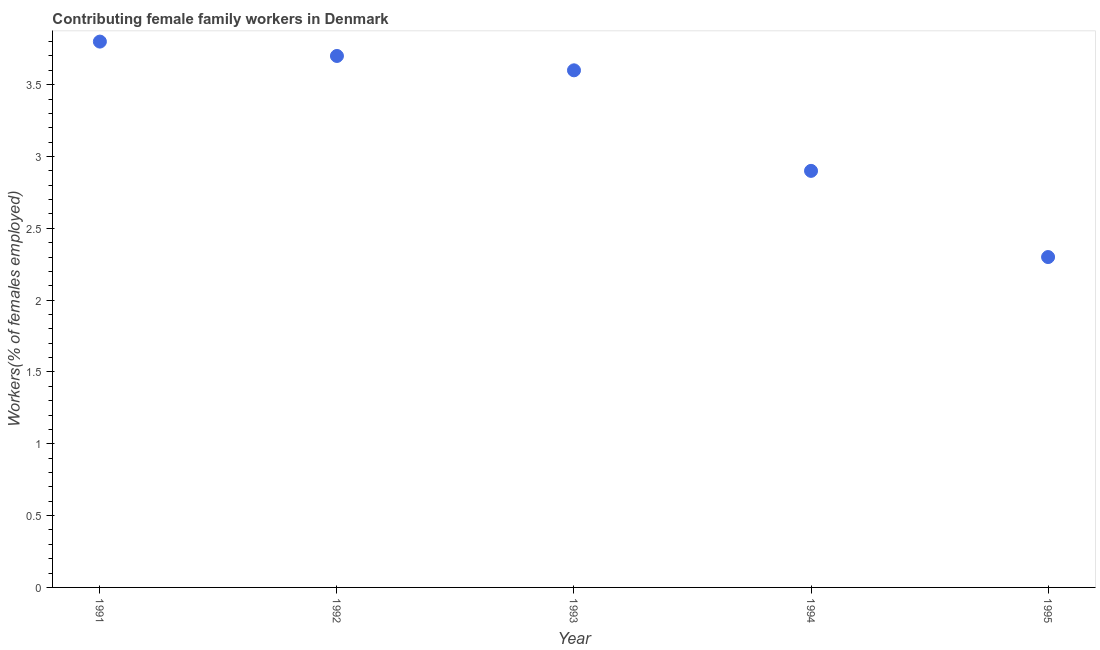What is the contributing female family workers in 1992?
Your answer should be compact. 3.7. Across all years, what is the maximum contributing female family workers?
Provide a succinct answer. 3.8. Across all years, what is the minimum contributing female family workers?
Your answer should be compact. 2.3. What is the sum of the contributing female family workers?
Make the answer very short. 16.3. What is the difference between the contributing female family workers in 1992 and 1993?
Provide a short and direct response. 0.1. What is the average contributing female family workers per year?
Offer a very short reply. 3.26. What is the median contributing female family workers?
Make the answer very short. 3.6. Do a majority of the years between 1992 and 1993 (inclusive) have contributing female family workers greater than 1.2 %?
Keep it short and to the point. Yes. What is the ratio of the contributing female family workers in 1993 to that in 1994?
Offer a very short reply. 1.24. What is the difference between the highest and the second highest contributing female family workers?
Provide a succinct answer. 0.1. How many dotlines are there?
Ensure brevity in your answer.  1. How many years are there in the graph?
Provide a short and direct response. 5. Does the graph contain any zero values?
Provide a short and direct response. No. Does the graph contain grids?
Offer a very short reply. No. What is the title of the graph?
Offer a terse response. Contributing female family workers in Denmark. What is the label or title of the Y-axis?
Your answer should be very brief. Workers(% of females employed). What is the Workers(% of females employed) in 1991?
Make the answer very short. 3.8. What is the Workers(% of females employed) in 1992?
Your answer should be very brief. 3.7. What is the Workers(% of females employed) in 1993?
Your answer should be compact. 3.6. What is the Workers(% of females employed) in 1994?
Keep it short and to the point. 2.9. What is the Workers(% of females employed) in 1995?
Keep it short and to the point. 2.3. What is the difference between the Workers(% of females employed) in 1991 and 1994?
Provide a short and direct response. 0.9. What is the difference between the Workers(% of females employed) in 1991 and 1995?
Provide a succinct answer. 1.5. What is the difference between the Workers(% of females employed) in 1992 and 1995?
Your answer should be very brief. 1.4. What is the ratio of the Workers(% of females employed) in 1991 to that in 1992?
Give a very brief answer. 1.03. What is the ratio of the Workers(% of females employed) in 1991 to that in 1993?
Your response must be concise. 1.06. What is the ratio of the Workers(% of females employed) in 1991 to that in 1994?
Your answer should be compact. 1.31. What is the ratio of the Workers(% of females employed) in 1991 to that in 1995?
Your response must be concise. 1.65. What is the ratio of the Workers(% of females employed) in 1992 to that in 1993?
Ensure brevity in your answer.  1.03. What is the ratio of the Workers(% of females employed) in 1992 to that in 1994?
Give a very brief answer. 1.28. What is the ratio of the Workers(% of females employed) in 1992 to that in 1995?
Make the answer very short. 1.61. What is the ratio of the Workers(% of females employed) in 1993 to that in 1994?
Your response must be concise. 1.24. What is the ratio of the Workers(% of females employed) in 1993 to that in 1995?
Your response must be concise. 1.56. What is the ratio of the Workers(% of females employed) in 1994 to that in 1995?
Your response must be concise. 1.26. 